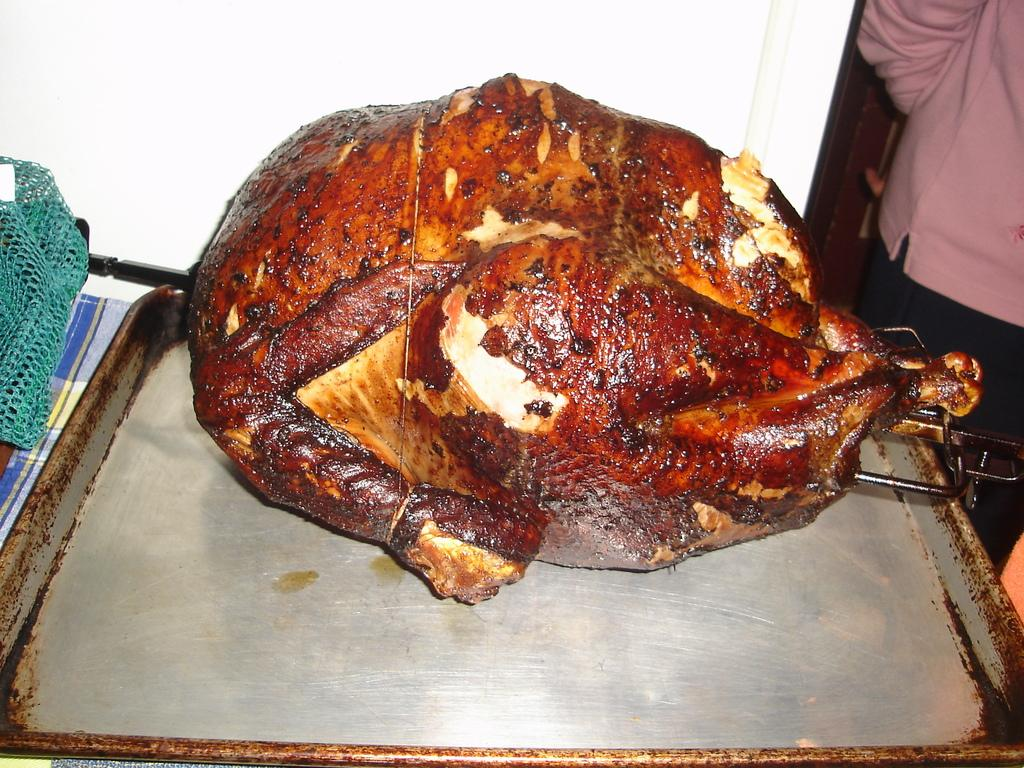What is the main subject in the image? There is a food item in a tray in the image. What can be seen in the background of the image? There is a wall in the background of the image. Is there a person visible in the image? Yes, there is a person standing to the right side of the image. What type of rod is the person using to create the food item in the image? There is no rod visible in the image, and the person is not creating the food item; it is already in the tray. 